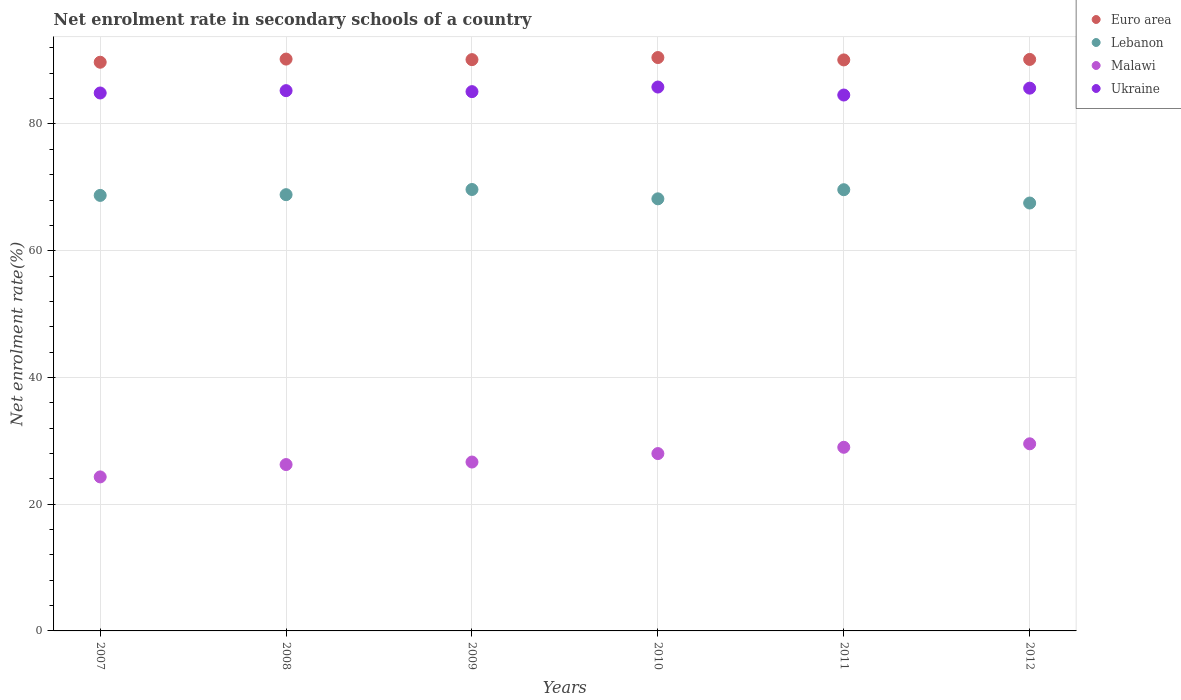How many different coloured dotlines are there?
Your response must be concise. 4. Is the number of dotlines equal to the number of legend labels?
Ensure brevity in your answer.  Yes. What is the net enrolment rate in secondary schools in Lebanon in 2010?
Provide a succinct answer. 68.18. Across all years, what is the maximum net enrolment rate in secondary schools in Malawi?
Offer a terse response. 29.53. Across all years, what is the minimum net enrolment rate in secondary schools in Lebanon?
Offer a terse response. 67.52. In which year was the net enrolment rate in secondary schools in Lebanon maximum?
Provide a succinct answer. 2009. In which year was the net enrolment rate in secondary schools in Ukraine minimum?
Offer a terse response. 2011. What is the total net enrolment rate in secondary schools in Malawi in the graph?
Keep it short and to the point. 163.7. What is the difference between the net enrolment rate in secondary schools in Ukraine in 2007 and that in 2008?
Offer a very short reply. -0.37. What is the difference between the net enrolment rate in secondary schools in Malawi in 2009 and the net enrolment rate in secondary schools in Ukraine in 2012?
Ensure brevity in your answer.  -59. What is the average net enrolment rate in secondary schools in Malawi per year?
Your answer should be very brief. 27.28. In the year 2009, what is the difference between the net enrolment rate in secondary schools in Malawi and net enrolment rate in secondary schools in Ukraine?
Your response must be concise. -58.45. In how many years, is the net enrolment rate in secondary schools in Euro area greater than 40 %?
Offer a very short reply. 6. What is the ratio of the net enrolment rate in secondary schools in Ukraine in 2008 to that in 2009?
Provide a short and direct response. 1. Is the net enrolment rate in secondary schools in Malawi in 2008 less than that in 2012?
Your response must be concise. Yes. What is the difference between the highest and the second highest net enrolment rate in secondary schools in Malawi?
Offer a very short reply. 0.55. What is the difference between the highest and the lowest net enrolment rate in secondary schools in Euro area?
Provide a succinct answer. 0.74. In how many years, is the net enrolment rate in secondary schools in Lebanon greater than the average net enrolment rate in secondary schools in Lebanon taken over all years?
Your answer should be compact. 3. Does the net enrolment rate in secondary schools in Malawi monotonically increase over the years?
Your answer should be very brief. Yes. Is the net enrolment rate in secondary schools in Euro area strictly less than the net enrolment rate in secondary schools in Lebanon over the years?
Your answer should be compact. No. How many dotlines are there?
Your answer should be very brief. 4. What is the difference between two consecutive major ticks on the Y-axis?
Your answer should be compact. 20. Are the values on the major ticks of Y-axis written in scientific E-notation?
Make the answer very short. No. Does the graph contain any zero values?
Make the answer very short. No. Does the graph contain grids?
Ensure brevity in your answer.  Yes. What is the title of the graph?
Ensure brevity in your answer.  Net enrolment rate in secondary schools of a country. What is the label or title of the X-axis?
Your answer should be very brief. Years. What is the label or title of the Y-axis?
Provide a succinct answer. Net enrolment rate(%). What is the Net enrolment rate(%) of Euro area in 2007?
Offer a very short reply. 89.74. What is the Net enrolment rate(%) of Lebanon in 2007?
Offer a terse response. 68.73. What is the Net enrolment rate(%) of Malawi in 2007?
Keep it short and to the point. 24.3. What is the Net enrolment rate(%) of Ukraine in 2007?
Ensure brevity in your answer.  84.89. What is the Net enrolment rate(%) in Euro area in 2008?
Provide a short and direct response. 90.24. What is the Net enrolment rate(%) of Lebanon in 2008?
Your response must be concise. 68.84. What is the Net enrolment rate(%) of Malawi in 2008?
Provide a succinct answer. 26.25. What is the Net enrolment rate(%) in Ukraine in 2008?
Your answer should be very brief. 85.26. What is the Net enrolment rate(%) of Euro area in 2009?
Your response must be concise. 90.15. What is the Net enrolment rate(%) in Lebanon in 2009?
Provide a succinct answer. 69.66. What is the Net enrolment rate(%) of Malawi in 2009?
Keep it short and to the point. 26.65. What is the Net enrolment rate(%) of Ukraine in 2009?
Your response must be concise. 85.1. What is the Net enrolment rate(%) of Euro area in 2010?
Offer a very short reply. 90.48. What is the Net enrolment rate(%) in Lebanon in 2010?
Your answer should be very brief. 68.18. What is the Net enrolment rate(%) in Malawi in 2010?
Your response must be concise. 27.99. What is the Net enrolment rate(%) of Ukraine in 2010?
Your answer should be very brief. 85.83. What is the Net enrolment rate(%) in Euro area in 2011?
Keep it short and to the point. 90.1. What is the Net enrolment rate(%) in Lebanon in 2011?
Your response must be concise. 69.62. What is the Net enrolment rate(%) of Malawi in 2011?
Provide a succinct answer. 28.98. What is the Net enrolment rate(%) in Ukraine in 2011?
Your answer should be very brief. 84.57. What is the Net enrolment rate(%) of Euro area in 2012?
Give a very brief answer. 90.18. What is the Net enrolment rate(%) in Lebanon in 2012?
Offer a terse response. 67.52. What is the Net enrolment rate(%) of Malawi in 2012?
Keep it short and to the point. 29.53. What is the Net enrolment rate(%) of Ukraine in 2012?
Give a very brief answer. 85.65. Across all years, what is the maximum Net enrolment rate(%) in Euro area?
Your answer should be compact. 90.48. Across all years, what is the maximum Net enrolment rate(%) of Lebanon?
Your answer should be very brief. 69.66. Across all years, what is the maximum Net enrolment rate(%) in Malawi?
Your response must be concise. 29.53. Across all years, what is the maximum Net enrolment rate(%) in Ukraine?
Keep it short and to the point. 85.83. Across all years, what is the minimum Net enrolment rate(%) in Euro area?
Provide a succinct answer. 89.74. Across all years, what is the minimum Net enrolment rate(%) of Lebanon?
Your answer should be very brief. 67.52. Across all years, what is the minimum Net enrolment rate(%) in Malawi?
Offer a terse response. 24.3. Across all years, what is the minimum Net enrolment rate(%) of Ukraine?
Offer a very short reply. 84.57. What is the total Net enrolment rate(%) in Euro area in the graph?
Your answer should be very brief. 540.89. What is the total Net enrolment rate(%) of Lebanon in the graph?
Your answer should be very brief. 412.55. What is the total Net enrolment rate(%) of Malawi in the graph?
Your answer should be compact. 163.7. What is the total Net enrolment rate(%) in Ukraine in the graph?
Your answer should be very brief. 511.28. What is the difference between the Net enrolment rate(%) in Euro area in 2007 and that in 2008?
Your answer should be very brief. -0.5. What is the difference between the Net enrolment rate(%) in Lebanon in 2007 and that in 2008?
Offer a very short reply. -0.12. What is the difference between the Net enrolment rate(%) in Malawi in 2007 and that in 2008?
Offer a terse response. -1.95. What is the difference between the Net enrolment rate(%) in Ukraine in 2007 and that in 2008?
Keep it short and to the point. -0.37. What is the difference between the Net enrolment rate(%) of Euro area in 2007 and that in 2009?
Offer a terse response. -0.41. What is the difference between the Net enrolment rate(%) in Lebanon in 2007 and that in 2009?
Make the answer very short. -0.93. What is the difference between the Net enrolment rate(%) in Malawi in 2007 and that in 2009?
Offer a terse response. -2.35. What is the difference between the Net enrolment rate(%) of Ukraine in 2007 and that in 2009?
Offer a very short reply. -0.21. What is the difference between the Net enrolment rate(%) of Euro area in 2007 and that in 2010?
Your answer should be very brief. -0.74. What is the difference between the Net enrolment rate(%) of Lebanon in 2007 and that in 2010?
Give a very brief answer. 0.54. What is the difference between the Net enrolment rate(%) in Malawi in 2007 and that in 2010?
Your response must be concise. -3.68. What is the difference between the Net enrolment rate(%) in Ukraine in 2007 and that in 2010?
Ensure brevity in your answer.  -0.94. What is the difference between the Net enrolment rate(%) of Euro area in 2007 and that in 2011?
Ensure brevity in your answer.  -0.37. What is the difference between the Net enrolment rate(%) of Lebanon in 2007 and that in 2011?
Give a very brief answer. -0.9. What is the difference between the Net enrolment rate(%) of Malawi in 2007 and that in 2011?
Make the answer very short. -4.67. What is the difference between the Net enrolment rate(%) in Ukraine in 2007 and that in 2011?
Offer a very short reply. 0.32. What is the difference between the Net enrolment rate(%) of Euro area in 2007 and that in 2012?
Give a very brief answer. -0.44. What is the difference between the Net enrolment rate(%) in Lebanon in 2007 and that in 2012?
Offer a very short reply. 1.2. What is the difference between the Net enrolment rate(%) of Malawi in 2007 and that in 2012?
Provide a succinct answer. -5.22. What is the difference between the Net enrolment rate(%) in Ukraine in 2007 and that in 2012?
Offer a very short reply. -0.76. What is the difference between the Net enrolment rate(%) in Euro area in 2008 and that in 2009?
Ensure brevity in your answer.  0.09. What is the difference between the Net enrolment rate(%) of Lebanon in 2008 and that in 2009?
Give a very brief answer. -0.82. What is the difference between the Net enrolment rate(%) in Malawi in 2008 and that in 2009?
Keep it short and to the point. -0.4. What is the difference between the Net enrolment rate(%) in Ukraine in 2008 and that in 2009?
Offer a terse response. 0.16. What is the difference between the Net enrolment rate(%) of Euro area in 2008 and that in 2010?
Provide a succinct answer. -0.24. What is the difference between the Net enrolment rate(%) of Lebanon in 2008 and that in 2010?
Your answer should be compact. 0.66. What is the difference between the Net enrolment rate(%) of Malawi in 2008 and that in 2010?
Your response must be concise. -1.73. What is the difference between the Net enrolment rate(%) in Ukraine in 2008 and that in 2010?
Offer a terse response. -0.57. What is the difference between the Net enrolment rate(%) of Euro area in 2008 and that in 2011?
Offer a very short reply. 0.13. What is the difference between the Net enrolment rate(%) of Lebanon in 2008 and that in 2011?
Your response must be concise. -0.78. What is the difference between the Net enrolment rate(%) of Malawi in 2008 and that in 2011?
Your answer should be very brief. -2.73. What is the difference between the Net enrolment rate(%) in Ukraine in 2008 and that in 2011?
Provide a short and direct response. 0.69. What is the difference between the Net enrolment rate(%) in Euro area in 2008 and that in 2012?
Your answer should be compact. 0.05. What is the difference between the Net enrolment rate(%) in Lebanon in 2008 and that in 2012?
Your answer should be compact. 1.32. What is the difference between the Net enrolment rate(%) of Malawi in 2008 and that in 2012?
Your answer should be very brief. -3.28. What is the difference between the Net enrolment rate(%) of Ukraine in 2008 and that in 2012?
Your response must be concise. -0.39. What is the difference between the Net enrolment rate(%) in Euro area in 2009 and that in 2010?
Give a very brief answer. -0.33. What is the difference between the Net enrolment rate(%) in Lebanon in 2009 and that in 2010?
Give a very brief answer. 1.47. What is the difference between the Net enrolment rate(%) in Malawi in 2009 and that in 2010?
Offer a very short reply. -1.34. What is the difference between the Net enrolment rate(%) of Ukraine in 2009 and that in 2010?
Make the answer very short. -0.73. What is the difference between the Net enrolment rate(%) in Euro area in 2009 and that in 2011?
Provide a short and direct response. 0.05. What is the difference between the Net enrolment rate(%) in Lebanon in 2009 and that in 2011?
Offer a terse response. 0.03. What is the difference between the Net enrolment rate(%) of Malawi in 2009 and that in 2011?
Your answer should be compact. -2.33. What is the difference between the Net enrolment rate(%) in Ukraine in 2009 and that in 2011?
Your answer should be compact. 0.53. What is the difference between the Net enrolment rate(%) in Euro area in 2009 and that in 2012?
Give a very brief answer. -0.03. What is the difference between the Net enrolment rate(%) in Lebanon in 2009 and that in 2012?
Make the answer very short. 2.13. What is the difference between the Net enrolment rate(%) in Malawi in 2009 and that in 2012?
Give a very brief answer. -2.88. What is the difference between the Net enrolment rate(%) of Ukraine in 2009 and that in 2012?
Your answer should be compact. -0.55. What is the difference between the Net enrolment rate(%) of Euro area in 2010 and that in 2011?
Your response must be concise. 0.38. What is the difference between the Net enrolment rate(%) in Lebanon in 2010 and that in 2011?
Your response must be concise. -1.44. What is the difference between the Net enrolment rate(%) of Malawi in 2010 and that in 2011?
Your response must be concise. -0.99. What is the difference between the Net enrolment rate(%) in Ukraine in 2010 and that in 2011?
Your response must be concise. 1.26. What is the difference between the Net enrolment rate(%) in Euro area in 2010 and that in 2012?
Offer a terse response. 0.3. What is the difference between the Net enrolment rate(%) in Lebanon in 2010 and that in 2012?
Your answer should be compact. 0.66. What is the difference between the Net enrolment rate(%) in Malawi in 2010 and that in 2012?
Offer a very short reply. -1.54. What is the difference between the Net enrolment rate(%) of Ukraine in 2010 and that in 2012?
Give a very brief answer. 0.18. What is the difference between the Net enrolment rate(%) of Euro area in 2011 and that in 2012?
Ensure brevity in your answer.  -0.08. What is the difference between the Net enrolment rate(%) in Lebanon in 2011 and that in 2012?
Keep it short and to the point. 2.1. What is the difference between the Net enrolment rate(%) in Malawi in 2011 and that in 2012?
Your answer should be compact. -0.55. What is the difference between the Net enrolment rate(%) of Ukraine in 2011 and that in 2012?
Give a very brief answer. -1.08. What is the difference between the Net enrolment rate(%) in Euro area in 2007 and the Net enrolment rate(%) in Lebanon in 2008?
Offer a terse response. 20.9. What is the difference between the Net enrolment rate(%) in Euro area in 2007 and the Net enrolment rate(%) in Malawi in 2008?
Provide a short and direct response. 63.49. What is the difference between the Net enrolment rate(%) in Euro area in 2007 and the Net enrolment rate(%) in Ukraine in 2008?
Provide a succinct answer. 4.48. What is the difference between the Net enrolment rate(%) in Lebanon in 2007 and the Net enrolment rate(%) in Malawi in 2008?
Your answer should be very brief. 42.47. What is the difference between the Net enrolment rate(%) of Lebanon in 2007 and the Net enrolment rate(%) of Ukraine in 2008?
Provide a short and direct response. -16.53. What is the difference between the Net enrolment rate(%) of Malawi in 2007 and the Net enrolment rate(%) of Ukraine in 2008?
Provide a short and direct response. -60.95. What is the difference between the Net enrolment rate(%) in Euro area in 2007 and the Net enrolment rate(%) in Lebanon in 2009?
Your response must be concise. 20.08. What is the difference between the Net enrolment rate(%) in Euro area in 2007 and the Net enrolment rate(%) in Malawi in 2009?
Ensure brevity in your answer.  63.09. What is the difference between the Net enrolment rate(%) of Euro area in 2007 and the Net enrolment rate(%) of Ukraine in 2009?
Your answer should be very brief. 4.64. What is the difference between the Net enrolment rate(%) of Lebanon in 2007 and the Net enrolment rate(%) of Malawi in 2009?
Ensure brevity in your answer.  42.08. What is the difference between the Net enrolment rate(%) in Lebanon in 2007 and the Net enrolment rate(%) in Ukraine in 2009?
Give a very brief answer. -16.37. What is the difference between the Net enrolment rate(%) of Malawi in 2007 and the Net enrolment rate(%) of Ukraine in 2009?
Make the answer very short. -60.8. What is the difference between the Net enrolment rate(%) in Euro area in 2007 and the Net enrolment rate(%) in Lebanon in 2010?
Your answer should be compact. 21.55. What is the difference between the Net enrolment rate(%) of Euro area in 2007 and the Net enrolment rate(%) of Malawi in 2010?
Your response must be concise. 61.75. What is the difference between the Net enrolment rate(%) in Euro area in 2007 and the Net enrolment rate(%) in Ukraine in 2010?
Your answer should be very brief. 3.91. What is the difference between the Net enrolment rate(%) of Lebanon in 2007 and the Net enrolment rate(%) of Malawi in 2010?
Offer a terse response. 40.74. What is the difference between the Net enrolment rate(%) of Lebanon in 2007 and the Net enrolment rate(%) of Ukraine in 2010?
Your answer should be very brief. -17.1. What is the difference between the Net enrolment rate(%) in Malawi in 2007 and the Net enrolment rate(%) in Ukraine in 2010?
Keep it short and to the point. -61.52. What is the difference between the Net enrolment rate(%) in Euro area in 2007 and the Net enrolment rate(%) in Lebanon in 2011?
Provide a short and direct response. 20.12. What is the difference between the Net enrolment rate(%) in Euro area in 2007 and the Net enrolment rate(%) in Malawi in 2011?
Ensure brevity in your answer.  60.76. What is the difference between the Net enrolment rate(%) in Euro area in 2007 and the Net enrolment rate(%) in Ukraine in 2011?
Make the answer very short. 5.17. What is the difference between the Net enrolment rate(%) of Lebanon in 2007 and the Net enrolment rate(%) of Malawi in 2011?
Ensure brevity in your answer.  39.75. What is the difference between the Net enrolment rate(%) of Lebanon in 2007 and the Net enrolment rate(%) of Ukraine in 2011?
Your answer should be very brief. -15.84. What is the difference between the Net enrolment rate(%) of Malawi in 2007 and the Net enrolment rate(%) of Ukraine in 2011?
Your answer should be very brief. -60.26. What is the difference between the Net enrolment rate(%) of Euro area in 2007 and the Net enrolment rate(%) of Lebanon in 2012?
Make the answer very short. 22.22. What is the difference between the Net enrolment rate(%) in Euro area in 2007 and the Net enrolment rate(%) in Malawi in 2012?
Your answer should be very brief. 60.21. What is the difference between the Net enrolment rate(%) of Euro area in 2007 and the Net enrolment rate(%) of Ukraine in 2012?
Your answer should be very brief. 4.09. What is the difference between the Net enrolment rate(%) in Lebanon in 2007 and the Net enrolment rate(%) in Malawi in 2012?
Your answer should be compact. 39.2. What is the difference between the Net enrolment rate(%) of Lebanon in 2007 and the Net enrolment rate(%) of Ukraine in 2012?
Offer a terse response. -16.92. What is the difference between the Net enrolment rate(%) of Malawi in 2007 and the Net enrolment rate(%) of Ukraine in 2012?
Make the answer very short. -61.35. What is the difference between the Net enrolment rate(%) in Euro area in 2008 and the Net enrolment rate(%) in Lebanon in 2009?
Provide a succinct answer. 20.58. What is the difference between the Net enrolment rate(%) of Euro area in 2008 and the Net enrolment rate(%) of Malawi in 2009?
Your answer should be compact. 63.59. What is the difference between the Net enrolment rate(%) of Euro area in 2008 and the Net enrolment rate(%) of Ukraine in 2009?
Your response must be concise. 5.14. What is the difference between the Net enrolment rate(%) of Lebanon in 2008 and the Net enrolment rate(%) of Malawi in 2009?
Provide a short and direct response. 42.19. What is the difference between the Net enrolment rate(%) of Lebanon in 2008 and the Net enrolment rate(%) of Ukraine in 2009?
Provide a short and direct response. -16.26. What is the difference between the Net enrolment rate(%) of Malawi in 2008 and the Net enrolment rate(%) of Ukraine in 2009?
Offer a terse response. -58.85. What is the difference between the Net enrolment rate(%) of Euro area in 2008 and the Net enrolment rate(%) of Lebanon in 2010?
Your answer should be very brief. 22.05. What is the difference between the Net enrolment rate(%) of Euro area in 2008 and the Net enrolment rate(%) of Malawi in 2010?
Offer a terse response. 62.25. What is the difference between the Net enrolment rate(%) of Euro area in 2008 and the Net enrolment rate(%) of Ukraine in 2010?
Your answer should be compact. 4.41. What is the difference between the Net enrolment rate(%) in Lebanon in 2008 and the Net enrolment rate(%) in Malawi in 2010?
Provide a succinct answer. 40.86. What is the difference between the Net enrolment rate(%) in Lebanon in 2008 and the Net enrolment rate(%) in Ukraine in 2010?
Provide a succinct answer. -16.98. What is the difference between the Net enrolment rate(%) in Malawi in 2008 and the Net enrolment rate(%) in Ukraine in 2010?
Offer a terse response. -59.57. What is the difference between the Net enrolment rate(%) of Euro area in 2008 and the Net enrolment rate(%) of Lebanon in 2011?
Provide a short and direct response. 20.61. What is the difference between the Net enrolment rate(%) in Euro area in 2008 and the Net enrolment rate(%) in Malawi in 2011?
Ensure brevity in your answer.  61.26. What is the difference between the Net enrolment rate(%) in Euro area in 2008 and the Net enrolment rate(%) in Ukraine in 2011?
Give a very brief answer. 5.67. What is the difference between the Net enrolment rate(%) in Lebanon in 2008 and the Net enrolment rate(%) in Malawi in 2011?
Keep it short and to the point. 39.86. What is the difference between the Net enrolment rate(%) in Lebanon in 2008 and the Net enrolment rate(%) in Ukraine in 2011?
Offer a very short reply. -15.72. What is the difference between the Net enrolment rate(%) of Malawi in 2008 and the Net enrolment rate(%) of Ukraine in 2011?
Provide a succinct answer. -58.31. What is the difference between the Net enrolment rate(%) of Euro area in 2008 and the Net enrolment rate(%) of Lebanon in 2012?
Keep it short and to the point. 22.71. What is the difference between the Net enrolment rate(%) in Euro area in 2008 and the Net enrolment rate(%) in Malawi in 2012?
Ensure brevity in your answer.  60.71. What is the difference between the Net enrolment rate(%) of Euro area in 2008 and the Net enrolment rate(%) of Ukraine in 2012?
Your response must be concise. 4.59. What is the difference between the Net enrolment rate(%) in Lebanon in 2008 and the Net enrolment rate(%) in Malawi in 2012?
Your answer should be very brief. 39.31. What is the difference between the Net enrolment rate(%) of Lebanon in 2008 and the Net enrolment rate(%) of Ukraine in 2012?
Provide a short and direct response. -16.81. What is the difference between the Net enrolment rate(%) in Malawi in 2008 and the Net enrolment rate(%) in Ukraine in 2012?
Make the answer very short. -59.4. What is the difference between the Net enrolment rate(%) of Euro area in 2009 and the Net enrolment rate(%) of Lebanon in 2010?
Make the answer very short. 21.97. What is the difference between the Net enrolment rate(%) in Euro area in 2009 and the Net enrolment rate(%) in Malawi in 2010?
Ensure brevity in your answer.  62.17. What is the difference between the Net enrolment rate(%) of Euro area in 2009 and the Net enrolment rate(%) of Ukraine in 2010?
Your answer should be compact. 4.33. What is the difference between the Net enrolment rate(%) in Lebanon in 2009 and the Net enrolment rate(%) in Malawi in 2010?
Offer a very short reply. 41.67. What is the difference between the Net enrolment rate(%) in Lebanon in 2009 and the Net enrolment rate(%) in Ukraine in 2010?
Provide a short and direct response. -16.17. What is the difference between the Net enrolment rate(%) in Malawi in 2009 and the Net enrolment rate(%) in Ukraine in 2010?
Offer a terse response. -59.18. What is the difference between the Net enrolment rate(%) in Euro area in 2009 and the Net enrolment rate(%) in Lebanon in 2011?
Offer a terse response. 20.53. What is the difference between the Net enrolment rate(%) in Euro area in 2009 and the Net enrolment rate(%) in Malawi in 2011?
Offer a terse response. 61.17. What is the difference between the Net enrolment rate(%) in Euro area in 2009 and the Net enrolment rate(%) in Ukraine in 2011?
Offer a very short reply. 5.58. What is the difference between the Net enrolment rate(%) of Lebanon in 2009 and the Net enrolment rate(%) of Malawi in 2011?
Keep it short and to the point. 40.68. What is the difference between the Net enrolment rate(%) in Lebanon in 2009 and the Net enrolment rate(%) in Ukraine in 2011?
Keep it short and to the point. -14.91. What is the difference between the Net enrolment rate(%) of Malawi in 2009 and the Net enrolment rate(%) of Ukraine in 2011?
Give a very brief answer. -57.92. What is the difference between the Net enrolment rate(%) in Euro area in 2009 and the Net enrolment rate(%) in Lebanon in 2012?
Offer a very short reply. 22.63. What is the difference between the Net enrolment rate(%) of Euro area in 2009 and the Net enrolment rate(%) of Malawi in 2012?
Offer a very short reply. 60.62. What is the difference between the Net enrolment rate(%) in Euro area in 2009 and the Net enrolment rate(%) in Ukraine in 2012?
Offer a terse response. 4.5. What is the difference between the Net enrolment rate(%) of Lebanon in 2009 and the Net enrolment rate(%) of Malawi in 2012?
Make the answer very short. 40.13. What is the difference between the Net enrolment rate(%) in Lebanon in 2009 and the Net enrolment rate(%) in Ukraine in 2012?
Your answer should be compact. -15.99. What is the difference between the Net enrolment rate(%) of Malawi in 2009 and the Net enrolment rate(%) of Ukraine in 2012?
Make the answer very short. -59. What is the difference between the Net enrolment rate(%) in Euro area in 2010 and the Net enrolment rate(%) in Lebanon in 2011?
Make the answer very short. 20.86. What is the difference between the Net enrolment rate(%) in Euro area in 2010 and the Net enrolment rate(%) in Malawi in 2011?
Provide a succinct answer. 61.5. What is the difference between the Net enrolment rate(%) in Euro area in 2010 and the Net enrolment rate(%) in Ukraine in 2011?
Your response must be concise. 5.91. What is the difference between the Net enrolment rate(%) in Lebanon in 2010 and the Net enrolment rate(%) in Malawi in 2011?
Ensure brevity in your answer.  39.21. What is the difference between the Net enrolment rate(%) in Lebanon in 2010 and the Net enrolment rate(%) in Ukraine in 2011?
Make the answer very short. -16.38. What is the difference between the Net enrolment rate(%) of Malawi in 2010 and the Net enrolment rate(%) of Ukraine in 2011?
Your response must be concise. -56.58. What is the difference between the Net enrolment rate(%) in Euro area in 2010 and the Net enrolment rate(%) in Lebanon in 2012?
Provide a short and direct response. 22.96. What is the difference between the Net enrolment rate(%) in Euro area in 2010 and the Net enrolment rate(%) in Malawi in 2012?
Offer a very short reply. 60.95. What is the difference between the Net enrolment rate(%) of Euro area in 2010 and the Net enrolment rate(%) of Ukraine in 2012?
Your answer should be compact. 4.83. What is the difference between the Net enrolment rate(%) of Lebanon in 2010 and the Net enrolment rate(%) of Malawi in 2012?
Your answer should be very brief. 38.66. What is the difference between the Net enrolment rate(%) of Lebanon in 2010 and the Net enrolment rate(%) of Ukraine in 2012?
Your answer should be very brief. -17.46. What is the difference between the Net enrolment rate(%) in Malawi in 2010 and the Net enrolment rate(%) in Ukraine in 2012?
Make the answer very short. -57.66. What is the difference between the Net enrolment rate(%) of Euro area in 2011 and the Net enrolment rate(%) of Lebanon in 2012?
Make the answer very short. 22.58. What is the difference between the Net enrolment rate(%) of Euro area in 2011 and the Net enrolment rate(%) of Malawi in 2012?
Give a very brief answer. 60.58. What is the difference between the Net enrolment rate(%) of Euro area in 2011 and the Net enrolment rate(%) of Ukraine in 2012?
Your response must be concise. 4.46. What is the difference between the Net enrolment rate(%) of Lebanon in 2011 and the Net enrolment rate(%) of Malawi in 2012?
Offer a terse response. 40.1. What is the difference between the Net enrolment rate(%) in Lebanon in 2011 and the Net enrolment rate(%) in Ukraine in 2012?
Keep it short and to the point. -16.03. What is the difference between the Net enrolment rate(%) of Malawi in 2011 and the Net enrolment rate(%) of Ukraine in 2012?
Your answer should be compact. -56.67. What is the average Net enrolment rate(%) of Euro area per year?
Ensure brevity in your answer.  90.15. What is the average Net enrolment rate(%) in Lebanon per year?
Keep it short and to the point. 68.76. What is the average Net enrolment rate(%) in Malawi per year?
Provide a short and direct response. 27.28. What is the average Net enrolment rate(%) of Ukraine per year?
Provide a succinct answer. 85.21. In the year 2007, what is the difference between the Net enrolment rate(%) in Euro area and Net enrolment rate(%) in Lebanon?
Your response must be concise. 21.01. In the year 2007, what is the difference between the Net enrolment rate(%) in Euro area and Net enrolment rate(%) in Malawi?
Give a very brief answer. 65.44. In the year 2007, what is the difference between the Net enrolment rate(%) in Euro area and Net enrolment rate(%) in Ukraine?
Give a very brief answer. 4.85. In the year 2007, what is the difference between the Net enrolment rate(%) in Lebanon and Net enrolment rate(%) in Malawi?
Your response must be concise. 44.42. In the year 2007, what is the difference between the Net enrolment rate(%) of Lebanon and Net enrolment rate(%) of Ukraine?
Offer a very short reply. -16.16. In the year 2007, what is the difference between the Net enrolment rate(%) of Malawi and Net enrolment rate(%) of Ukraine?
Your answer should be very brief. -60.58. In the year 2008, what is the difference between the Net enrolment rate(%) in Euro area and Net enrolment rate(%) in Lebanon?
Provide a short and direct response. 21.4. In the year 2008, what is the difference between the Net enrolment rate(%) of Euro area and Net enrolment rate(%) of Malawi?
Make the answer very short. 63.98. In the year 2008, what is the difference between the Net enrolment rate(%) in Euro area and Net enrolment rate(%) in Ukraine?
Ensure brevity in your answer.  4.98. In the year 2008, what is the difference between the Net enrolment rate(%) of Lebanon and Net enrolment rate(%) of Malawi?
Your answer should be very brief. 42.59. In the year 2008, what is the difference between the Net enrolment rate(%) in Lebanon and Net enrolment rate(%) in Ukraine?
Ensure brevity in your answer.  -16.42. In the year 2008, what is the difference between the Net enrolment rate(%) in Malawi and Net enrolment rate(%) in Ukraine?
Offer a very short reply. -59. In the year 2009, what is the difference between the Net enrolment rate(%) of Euro area and Net enrolment rate(%) of Lebanon?
Offer a very short reply. 20.49. In the year 2009, what is the difference between the Net enrolment rate(%) of Euro area and Net enrolment rate(%) of Malawi?
Make the answer very short. 63.5. In the year 2009, what is the difference between the Net enrolment rate(%) in Euro area and Net enrolment rate(%) in Ukraine?
Give a very brief answer. 5.05. In the year 2009, what is the difference between the Net enrolment rate(%) in Lebanon and Net enrolment rate(%) in Malawi?
Provide a succinct answer. 43.01. In the year 2009, what is the difference between the Net enrolment rate(%) of Lebanon and Net enrolment rate(%) of Ukraine?
Provide a succinct answer. -15.44. In the year 2009, what is the difference between the Net enrolment rate(%) of Malawi and Net enrolment rate(%) of Ukraine?
Give a very brief answer. -58.45. In the year 2010, what is the difference between the Net enrolment rate(%) of Euro area and Net enrolment rate(%) of Lebanon?
Make the answer very short. 22.3. In the year 2010, what is the difference between the Net enrolment rate(%) of Euro area and Net enrolment rate(%) of Malawi?
Give a very brief answer. 62.49. In the year 2010, what is the difference between the Net enrolment rate(%) in Euro area and Net enrolment rate(%) in Ukraine?
Provide a succinct answer. 4.65. In the year 2010, what is the difference between the Net enrolment rate(%) of Lebanon and Net enrolment rate(%) of Malawi?
Ensure brevity in your answer.  40.2. In the year 2010, what is the difference between the Net enrolment rate(%) in Lebanon and Net enrolment rate(%) in Ukraine?
Give a very brief answer. -17.64. In the year 2010, what is the difference between the Net enrolment rate(%) in Malawi and Net enrolment rate(%) in Ukraine?
Your answer should be very brief. -57.84. In the year 2011, what is the difference between the Net enrolment rate(%) in Euro area and Net enrolment rate(%) in Lebanon?
Give a very brief answer. 20.48. In the year 2011, what is the difference between the Net enrolment rate(%) of Euro area and Net enrolment rate(%) of Malawi?
Ensure brevity in your answer.  61.13. In the year 2011, what is the difference between the Net enrolment rate(%) in Euro area and Net enrolment rate(%) in Ukraine?
Your response must be concise. 5.54. In the year 2011, what is the difference between the Net enrolment rate(%) of Lebanon and Net enrolment rate(%) of Malawi?
Give a very brief answer. 40.65. In the year 2011, what is the difference between the Net enrolment rate(%) of Lebanon and Net enrolment rate(%) of Ukraine?
Offer a terse response. -14.94. In the year 2011, what is the difference between the Net enrolment rate(%) in Malawi and Net enrolment rate(%) in Ukraine?
Provide a short and direct response. -55.59. In the year 2012, what is the difference between the Net enrolment rate(%) in Euro area and Net enrolment rate(%) in Lebanon?
Provide a short and direct response. 22.66. In the year 2012, what is the difference between the Net enrolment rate(%) of Euro area and Net enrolment rate(%) of Malawi?
Offer a terse response. 60.66. In the year 2012, what is the difference between the Net enrolment rate(%) in Euro area and Net enrolment rate(%) in Ukraine?
Offer a very short reply. 4.53. In the year 2012, what is the difference between the Net enrolment rate(%) in Lebanon and Net enrolment rate(%) in Malawi?
Provide a short and direct response. 37.99. In the year 2012, what is the difference between the Net enrolment rate(%) of Lebanon and Net enrolment rate(%) of Ukraine?
Your answer should be very brief. -18.13. In the year 2012, what is the difference between the Net enrolment rate(%) in Malawi and Net enrolment rate(%) in Ukraine?
Keep it short and to the point. -56.12. What is the ratio of the Net enrolment rate(%) in Lebanon in 2007 to that in 2008?
Offer a terse response. 1. What is the ratio of the Net enrolment rate(%) of Malawi in 2007 to that in 2008?
Keep it short and to the point. 0.93. What is the ratio of the Net enrolment rate(%) of Lebanon in 2007 to that in 2009?
Make the answer very short. 0.99. What is the ratio of the Net enrolment rate(%) of Malawi in 2007 to that in 2009?
Make the answer very short. 0.91. What is the ratio of the Net enrolment rate(%) of Ukraine in 2007 to that in 2009?
Make the answer very short. 1. What is the ratio of the Net enrolment rate(%) in Lebanon in 2007 to that in 2010?
Keep it short and to the point. 1.01. What is the ratio of the Net enrolment rate(%) in Malawi in 2007 to that in 2010?
Ensure brevity in your answer.  0.87. What is the ratio of the Net enrolment rate(%) of Ukraine in 2007 to that in 2010?
Your answer should be compact. 0.99. What is the ratio of the Net enrolment rate(%) in Lebanon in 2007 to that in 2011?
Give a very brief answer. 0.99. What is the ratio of the Net enrolment rate(%) of Malawi in 2007 to that in 2011?
Offer a terse response. 0.84. What is the ratio of the Net enrolment rate(%) of Ukraine in 2007 to that in 2011?
Offer a terse response. 1. What is the ratio of the Net enrolment rate(%) in Lebanon in 2007 to that in 2012?
Ensure brevity in your answer.  1.02. What is the ratio of the Net enrolment rate(%) in Malawi in 2007 to that in 2012?
Keep it short and to the point. 0.82. What is the ratio of the Net enrolment rate(%) in Lebanon in 2008 to that in 2009?
Provide a short and direct response. 0.99. What is the ratio of the Net enrolment rate(%) of Malawi in 2008 to that in 2009?
Offer a terse response. 0.99. What is the ratio of the Net enrolment rate(%) of Lebanon in 2008 to that in 2010?
Your answer should be compact. 1.01. What is the ratio of the Net enrolment rate(%) in Malawi in 2008 to that in 2010?
Offer a very short reply. 0.94. What is the ratio of the Net enrolment rate(%) of Ukraine in 2008 to that in 2010?
Your answer should be very brief. 0.99. What is the ratio of the Net enrolment rate(%) of Malawi in 2008 to that in 2011?
Your response must be concise. 0.91. What is the ratio of the Net enrolment rate(%) of Ukraine in 2008 to that in 2011?
Your answer should be compact. 1.01. What is the ratio of the Net enrolment rate(%) in Euro area in 2008 to that in 2012?
Your answer should be very brief. 1. What is the ratio of the Net enrolment rate(%) in Lebanon in 2008 to that in 2012?
Give a very brief answer. 1.02. What is the ratio of the Net enrolment rate(%) in Malawi in 2008 to that in 2012?
Provide a succinct answer. 0.89. What is the ratio of the Net enrolment rate(%) in Ukraine in 2008 to that in 2012?
Provide a succinct answer. 1. What is the ratio of the Net enrolment rate(%) in Lebanon in 2009 to that in 2010?
Make the answer very short. 1.02. What is the ratio of the Net enrolment rate(%) in Malawi in 2009 to that in 2010?
Provide a succinct answer. 0.95. What is the ratio of the Net enrolment rate(%) of Lebanon in 2009 to that in 2011?
Give a very brief answer. 1. What is the ratio of the Net enrolment rate(%) of Malawi in 2009 to that in 2011?
Offer a very short reply. 0.92. What is the ratio of the Net enrolment rate(%) of Lebanon in 2009 to that in 2012?
Give a very brief answer. 1.03. What is the ratio of the Net enrolment rate(%) in Malawi in 2009 to that in 2012?
Keep it short and to the point. 0.9. What is the ratio of the Net enrolment rate(%) of Ukraine in 2009 to that in 2012?
Keep it short and to the point. 0.99. What is the ratio of the Net enrolment rate(%) in Euro area in 2010 to that in 2011?
Your answer should be compact. 1. What is the ratio of the Net enrolment rate(%) of Lebanon in 2010 to that in 2011?
Offer a terse response. 0.98. What is the ratio of the Net enrolment rate(%) of Malawi in 2010 to that in 2011?
Give a very brief answer. 0.97. What is the ratio of the Net enrolment rate(%) of Ukraine in 2010 to that in 2011?
Your response must be concise. 1.01. What is the ratio of the Net enrolment rate(%) of Euro area in 2010 to that in 2012?
Give a very brief answer. 1. What is the ratio of the Net enrolment rate(%) of Lebanon in 2010 to that in 2012?
Provide a succinct answer. 1.01. What is the ratio of the Net enrolment rate(%) of Malawi in 2010 to that in 2012?
Offer a terse response. 0.95. What is the ratio of the Net enrolment rate(%) of Euro area in 2011 to that in 2012?
Give a very brief answer. 1. What is the ratio of the Net enrolment rate(%) of Lebanon in 2011 to that in 2012?
Provide a short and direct response. 1.03. What is the ratio of the Net enrolment rate(%) in Malawi in 2011 to that in 2012?
Provide a short and direct response. 0.98. What is the ratio of the Net enrolment rate(%) in Ukraine in 2011 to that in 2012?
Ensure brevity in your answer.  0.99. What is the difference between the highest and the second highest Net enrolment rate(%) of Euro area?
Offer a terse response. 0.24. What is the difference between the highest and the second highest Net enrolment rate(%) in Lebanon?
Provide a succinct answer. 0.03. What is the difference between the highest and the second highest Net enrolment rate(%) of Malawi?
Ensure brevity in your answer.  0.55. What is the difference between the highest and the second highest Net enrolment rate(%) in Ukraine?
Give a very brief answer. 0.18. What is the difference between the highest and the lowest Net enrolment rate(%) in Euro area?
Ensure brevity in your answer.  0.74. What is the difference between the highest and the lowest Net enrolment rate(%) of Lebanon?
Your answer should be very brief. 2.13. What is the difference between the highest and the lowest Net enrolment rate(%) in Malawi?
Offer a terse response. 5.22. What is the difference between the highest and the lowest Net enrolment rate(%) of Ukraine?
Offer a terse response. 1.26. 